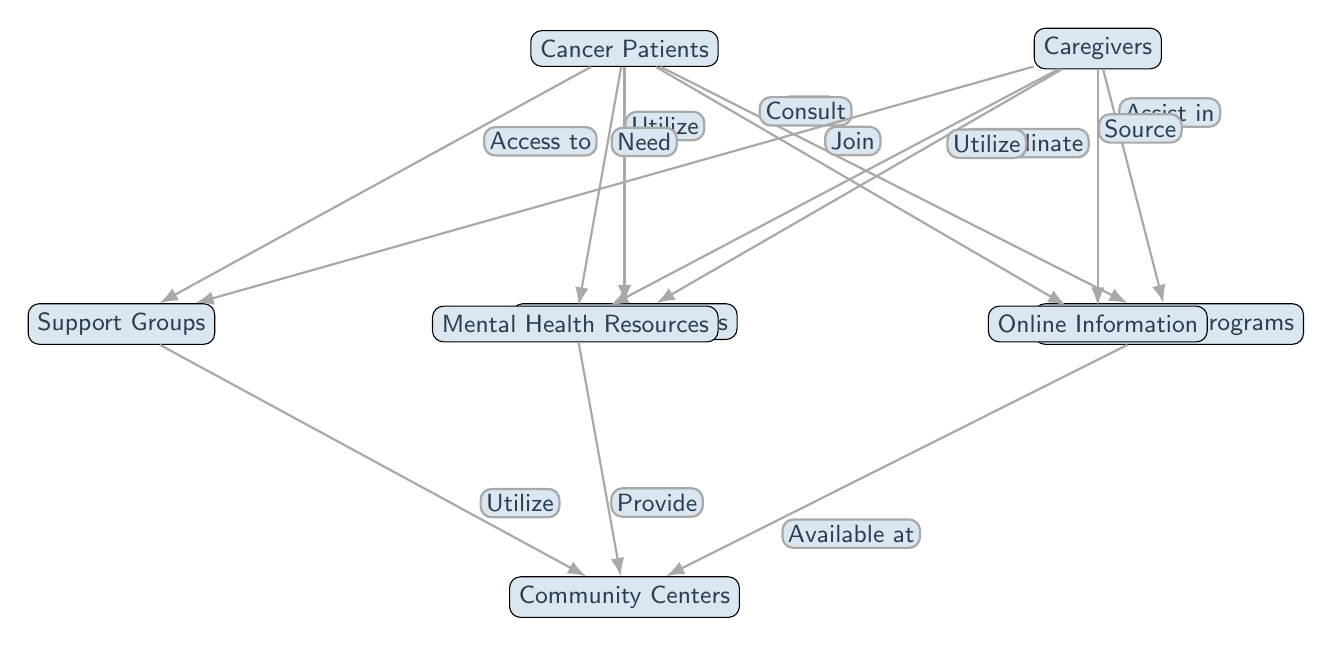What is the main focus of the diagram? The diagram centers around the accessibility and utilization of supportive services for cancer patients and caregivers. It showcases how different resources are interconnected concerning those two groups.
Answer: Resource Accessibility How many primary nodes are present in the diagram? There are six primary nodes identified: Cancer Patients, Caregivers, Support Groups, Healthcare Services, Financial Aid Programs, and Community Centers. Counting them gives us the answer.
Answer: Six What type of resource do cancer patients consult for online information? According to the diagram, cancer patients consult online resources specifically for information. This is indicated by the edge labeled "Consult."
Answer: Online Information Which resources do caregivers assist with in terms of financial aid? The caregivers assist with financial aid programs as indicated by the edge labeled "Assist in," showing their role in helping cancer patients access financial support.
Answer: Financial Aid Programs What is the relationship between support groups and community centers? Support groups have a utilization relationship with community centers, as shown by the edge labelled "Utilize," indicating that support groups make use of the resources available at community centers.
Answer: Utilize How do cancer patients interact with healthcare services? Cancer patients utilize healthcare services based on the edge labeled "Utilize," which specifies their active engagement with this resource to receive necessary medical support.
Answer: Utilize How do caregivers coordinate with healthcare services? The diagram indicates that caregivers coordinate with healthcare services, as represented by the edge labeled "Coordinate." This shows their collaborative role in managing patient care.
Answer: Coordinate In which context do mental health resources relate to community centers? Mental health resources provide services at community centers, as indicated by the edge labelled "Provide," meaning community centers host or support access to mental health services.
Answer: Provide How are financial aid programs represented in relation to community centers? Financial aid programs are available at community centers, as indicated by the edge labeled "Available at," showing that these financial resources can be accessed from community centers.
Answer: Available at 